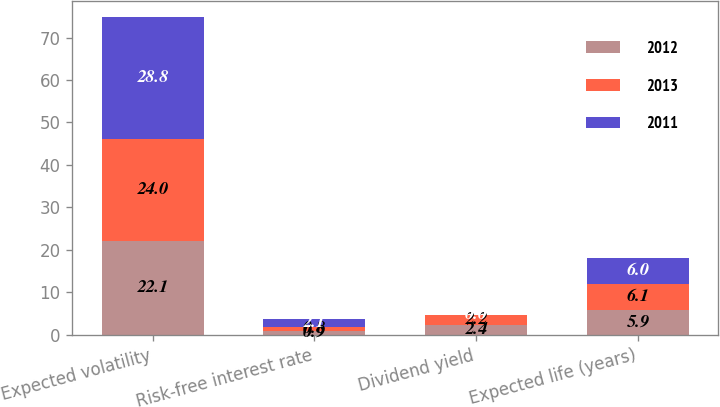<chart> <loc_0><loc_0><loc_500><loc_500><stacked_bar_chart><ecel><fcel>Expected volatility<fcel>Risk-free interest rate<fcel>Dividend yield<fcel>Expected life (years)<nl><fcel>2012<fcel>22.1<fcel>0.9<fcel>2.4<fcel>5.9<nl><fcel>2013<fcel>24<fcel>0.8<fcel>2.2<fcel>6.1<nl><fcel>2011<fcel>28.8<fcel>2.1<fcel>0<fcel>6<nl></chart> 